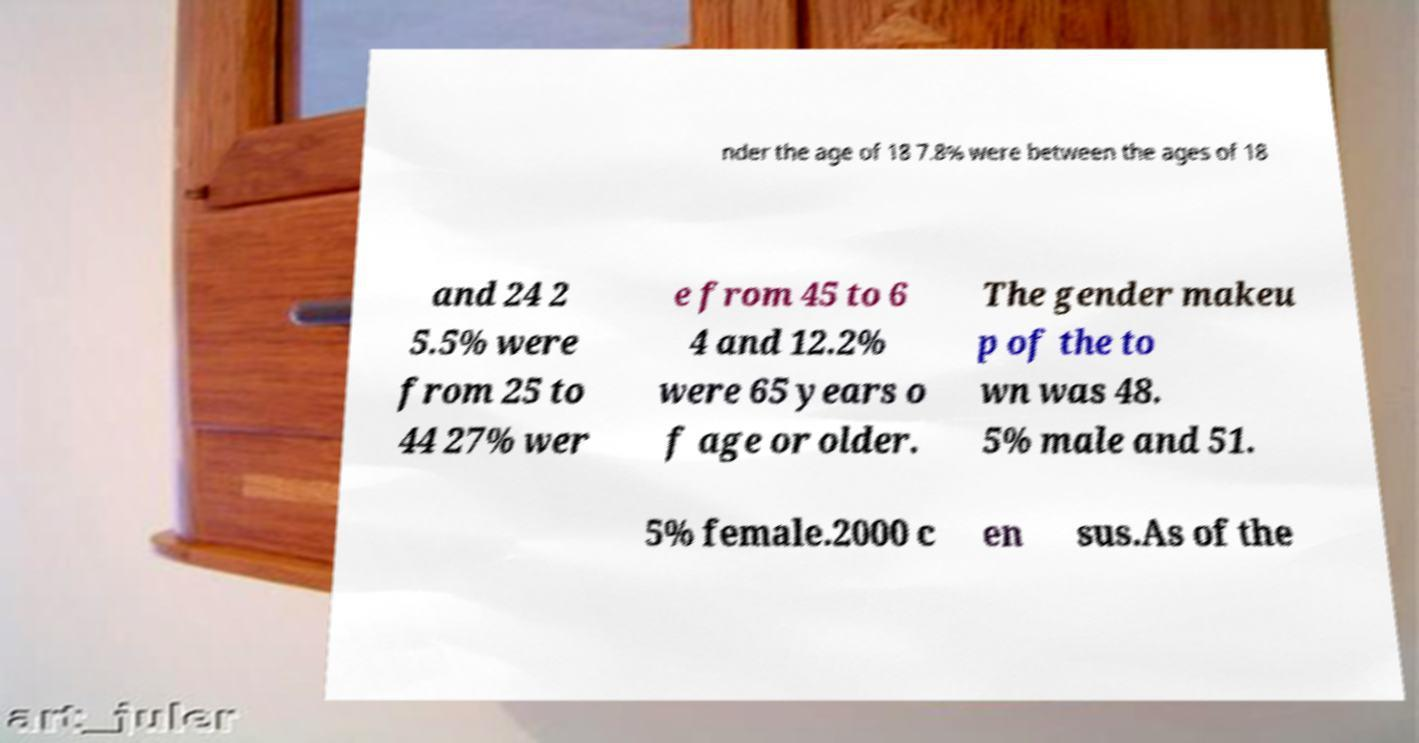I need the written content from this picture converted into text. Can you do that? nder the age of 18 7.8% were between the ages of 18 and 24 2 5.5% were from 25 to 44 27% wer e from 45 to 6 4 and 12.2% were 65 years o f age or older. The gender makeu p of the to wn was 48. 5% male and 51. 5% female.2000 c en sus.As of the 